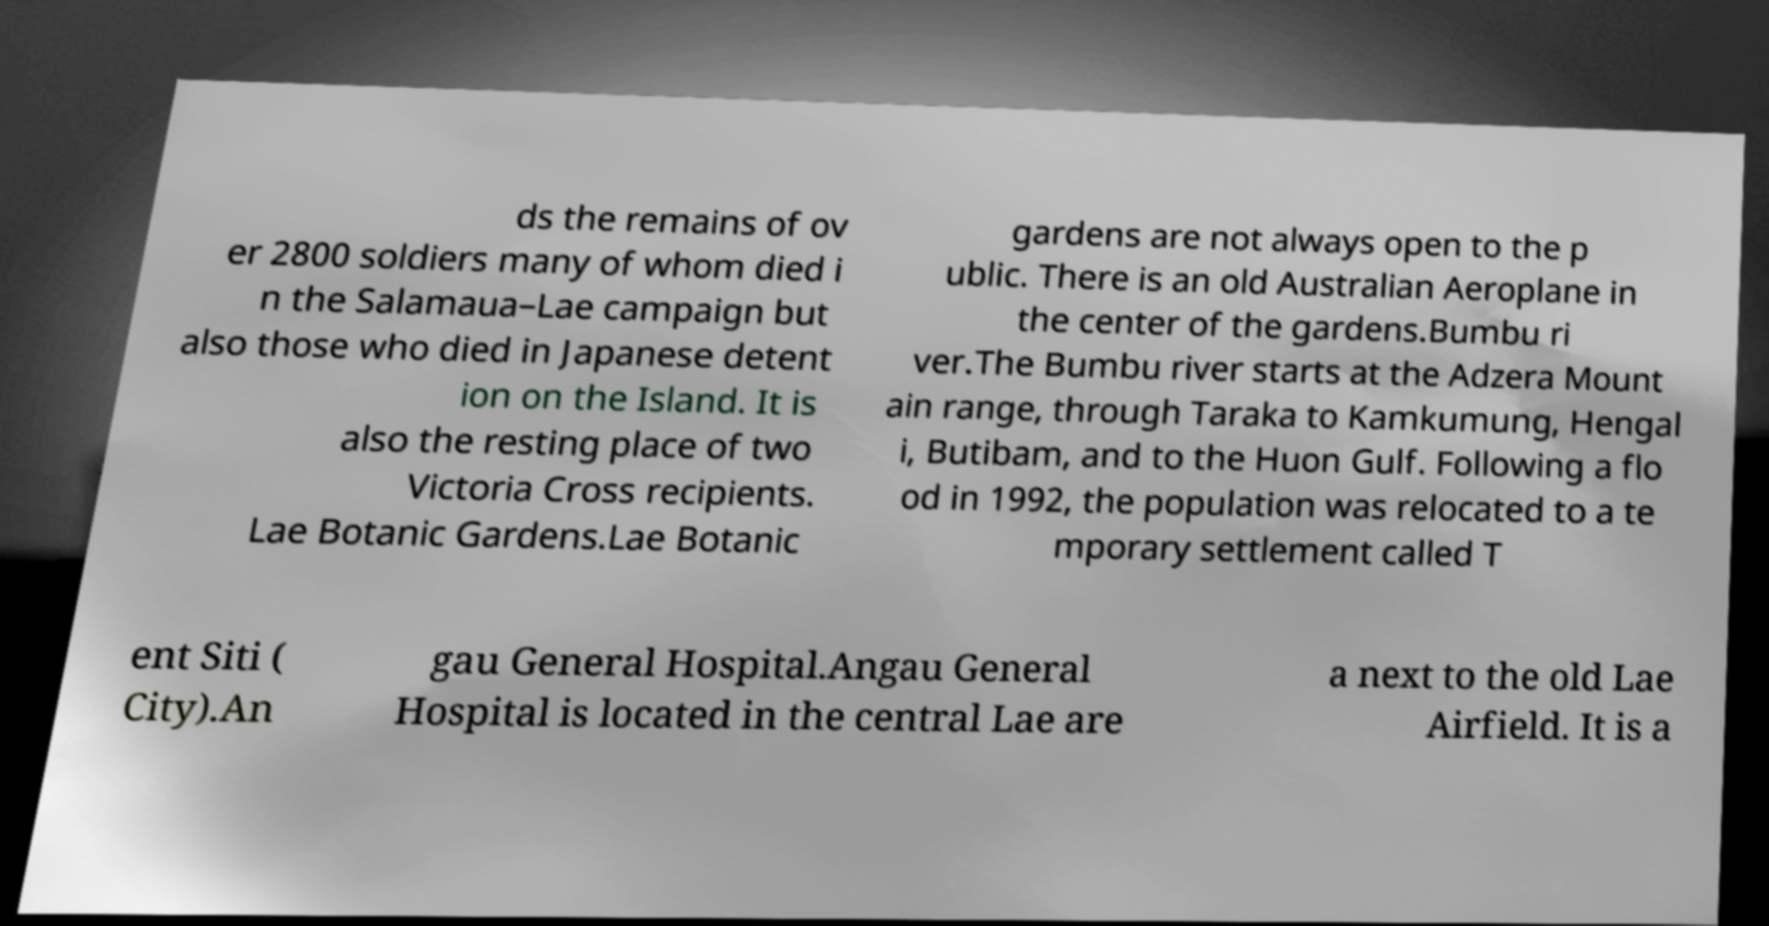Please identify and transcribe the text found in this image. ds the remains of ov er 2800 soldiers many of whom died i n the Salamaua–Lae campaign but also those who died in Japanese detent ion on the Island. It is also the resting place of two Victoria Cross recipients. Lae Botanic Gardens.Lae Botanic gardens are not always open to the p ublic. There is an old Australian Aeroplane in the center of the gardens.Bumbu ri ver.The Bumbu river starts at the Adzera Mount ain range, through Taraka to Kamkumung, Hengal i, Butibam, and to the Huon Gulf. Following a flo od in 1992, the population was relocated to a te mporary settlement called T ent Siti ( City).An gau General Hospital.Angau General Hospital is located in the central Lae are a next to the old Lae Airfield. It is a 